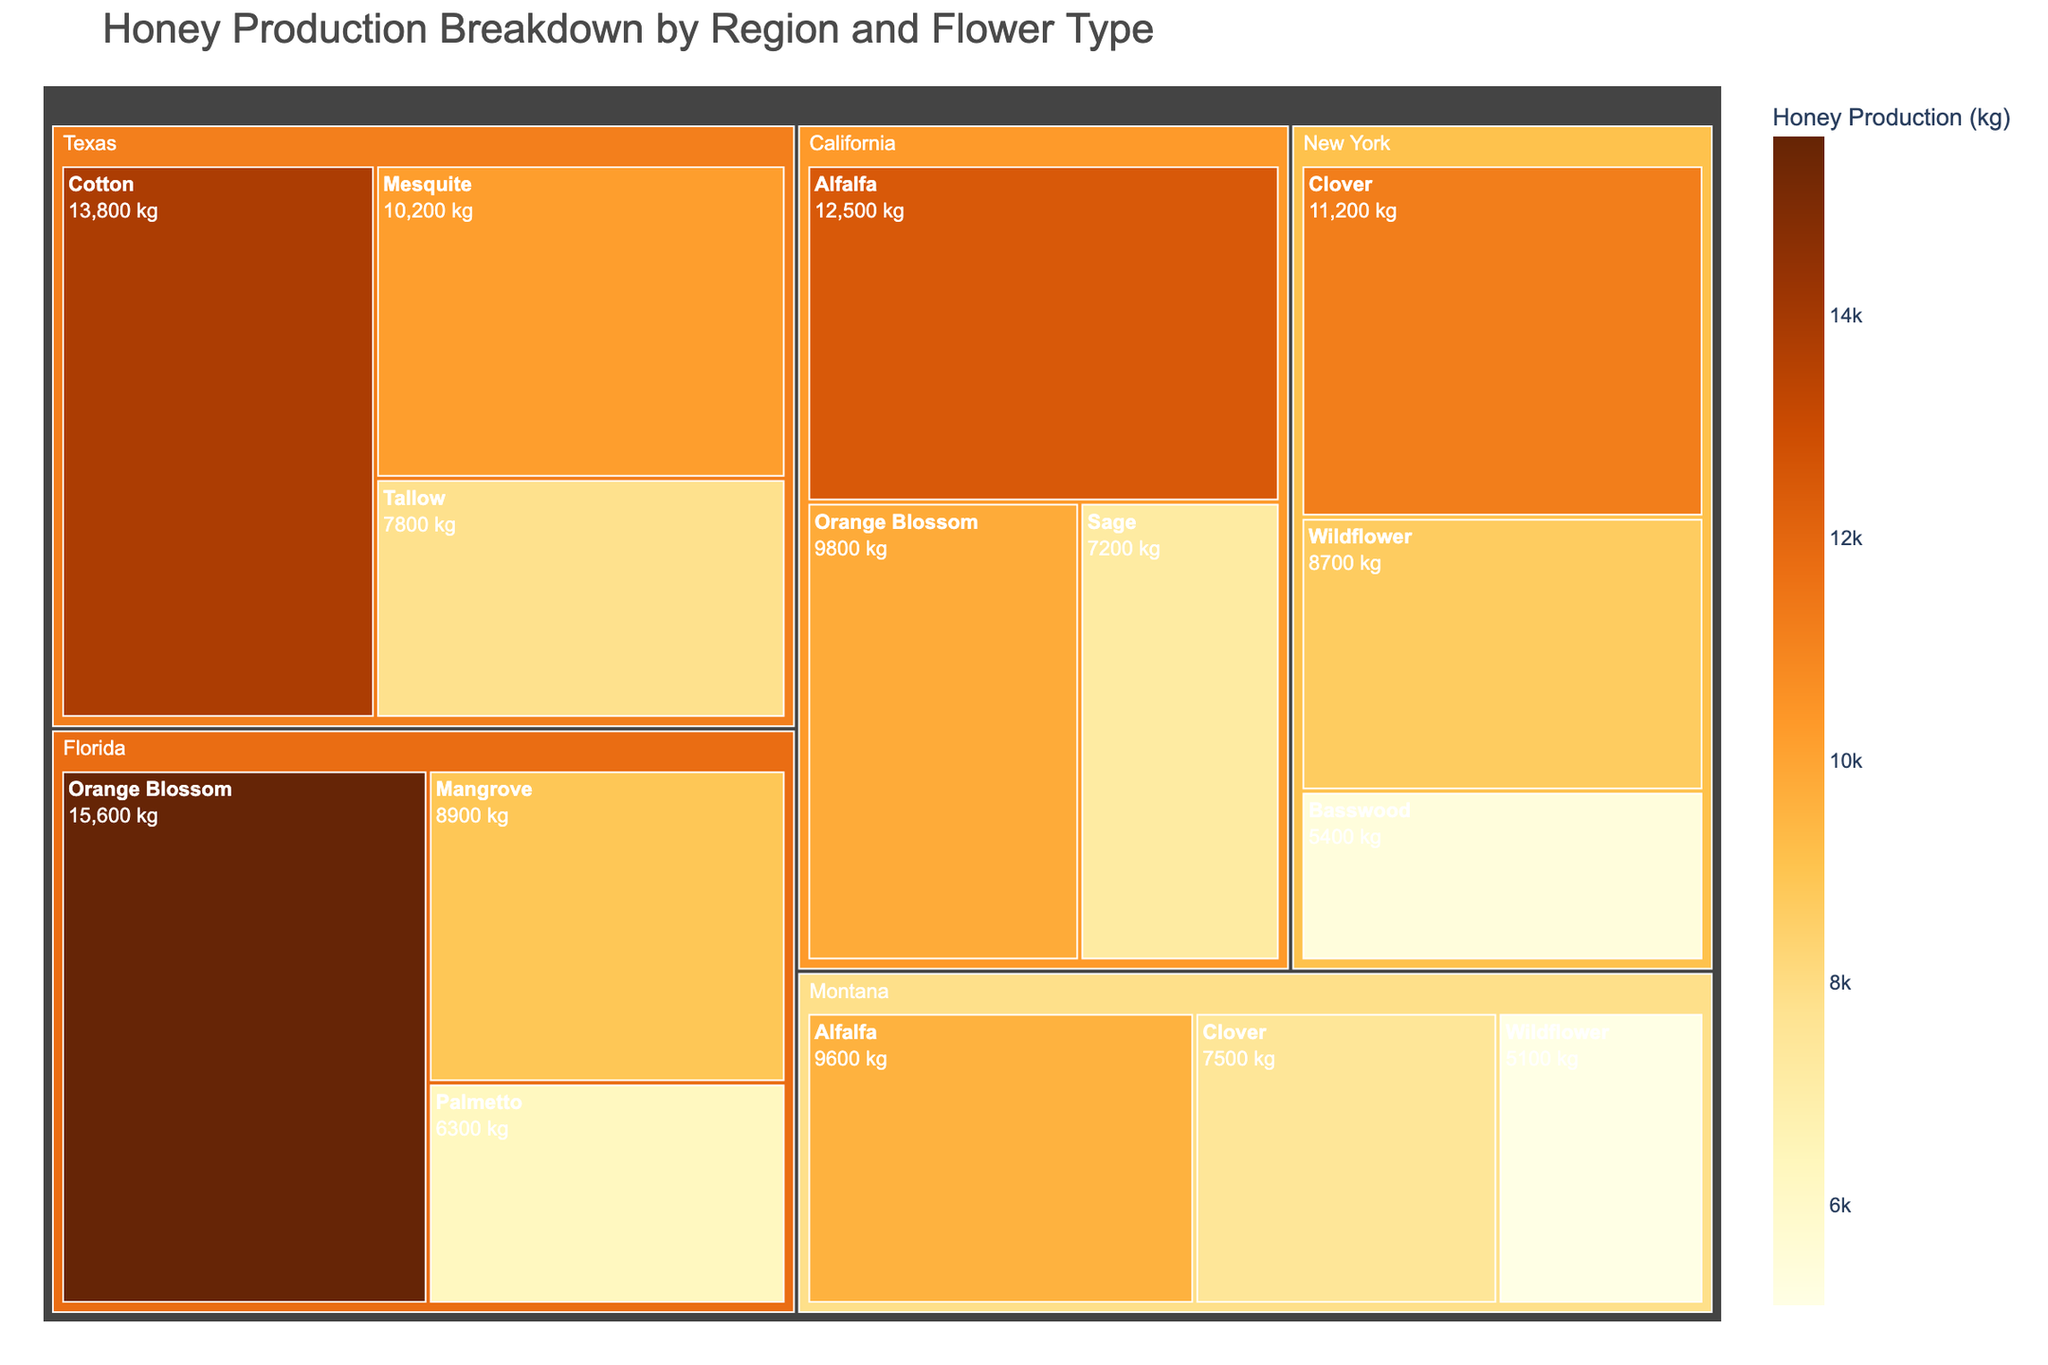What's the title of the figure? The title is usually located at the top of the figure, representing the main subject or data being visualized. In this case, the title can be seen at the top of the treemap.
Answer: Honey Production Breakdown by Region and Flower Type Which flower type in California has the highest honey production? By locating California in the treemap and examining the boxes within it, the Orange Blossom box has the largest size, indicating the highest honey production.
Answer: Orange Blossom How much honey is produced from Alfalfa in Montana? Locate Montana on the treemap, then find the Alfalfa section within Montana. The production amount is displayed in the section.
Answer: 9600 kg Which region has the lowest honey production from a single flower type? By examining all regions and their flower types, the smallest box signifies the lowest production. In New York, Basswood has the smallest box.
Answer: New York (Basswood) What is the total honey production in Texas? Find Texas on the treemap and sum the values for Cotton, Mesquite, and Tallow. Total = 13800 + 10200 + 7800.
Answer: 31800 kg How does honey production from Clover compare between New York and Montana? Locate Clover in both New York and Montana and compare the values. New York = 11200 kg, Montana = 7500 kg.
Answer: New York Clover has higher production Which flower type contributes the most to honey production in Florida? Within the Florida region on the treemap, the largest section belongs to the Orange Blossom flower.
Answer: Orange Blossom Is the total honey production higher in California or Florida? Sum the honey production values for all flower types in California and Florida. California total: 12500 + 9800 + 7200, Florida total: 15600 + 8900 + 6300. Compare the two sums.
Answer: Florida Which flower type has consistent honey production across multiple regions? Find a flower type that appears in multiple regions and compare its production values. Alfalfa appears in California and Montana.
Answer: Alfalfa What is the average honey production from Wildflower in New York and Montana? Sum the production values of Wildflower from both regions and divide by the number of regions. (8700 + 5100)/2.
Answer: 6900 kg 